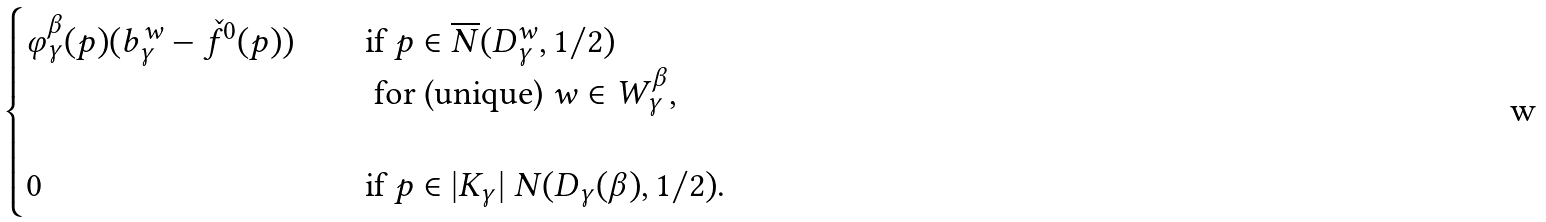<formula> <loc_0><loc_0><loc_500><loc_500>\begin{cases} \varphi _ { \gamma } ^ { \beta } ( p ) ( b _ { \gamma } ^ { w } - \check { f } ^ { 0 } ( p ) ) \quad & \text {if } p \in \overline { N } ( D _ { \gamma } ^ { w } , 1 / 2 ) \\ & \text { for (unique) } w \in W _ { \gamma } ^ { \beta } , \\ & \\ 0 \quad & \text {if } p \in | K _ { \gamma } | \ N ( D _ { \gamma } ( \beta ) , 1 / 2 ) . \end{cases}</formula> 